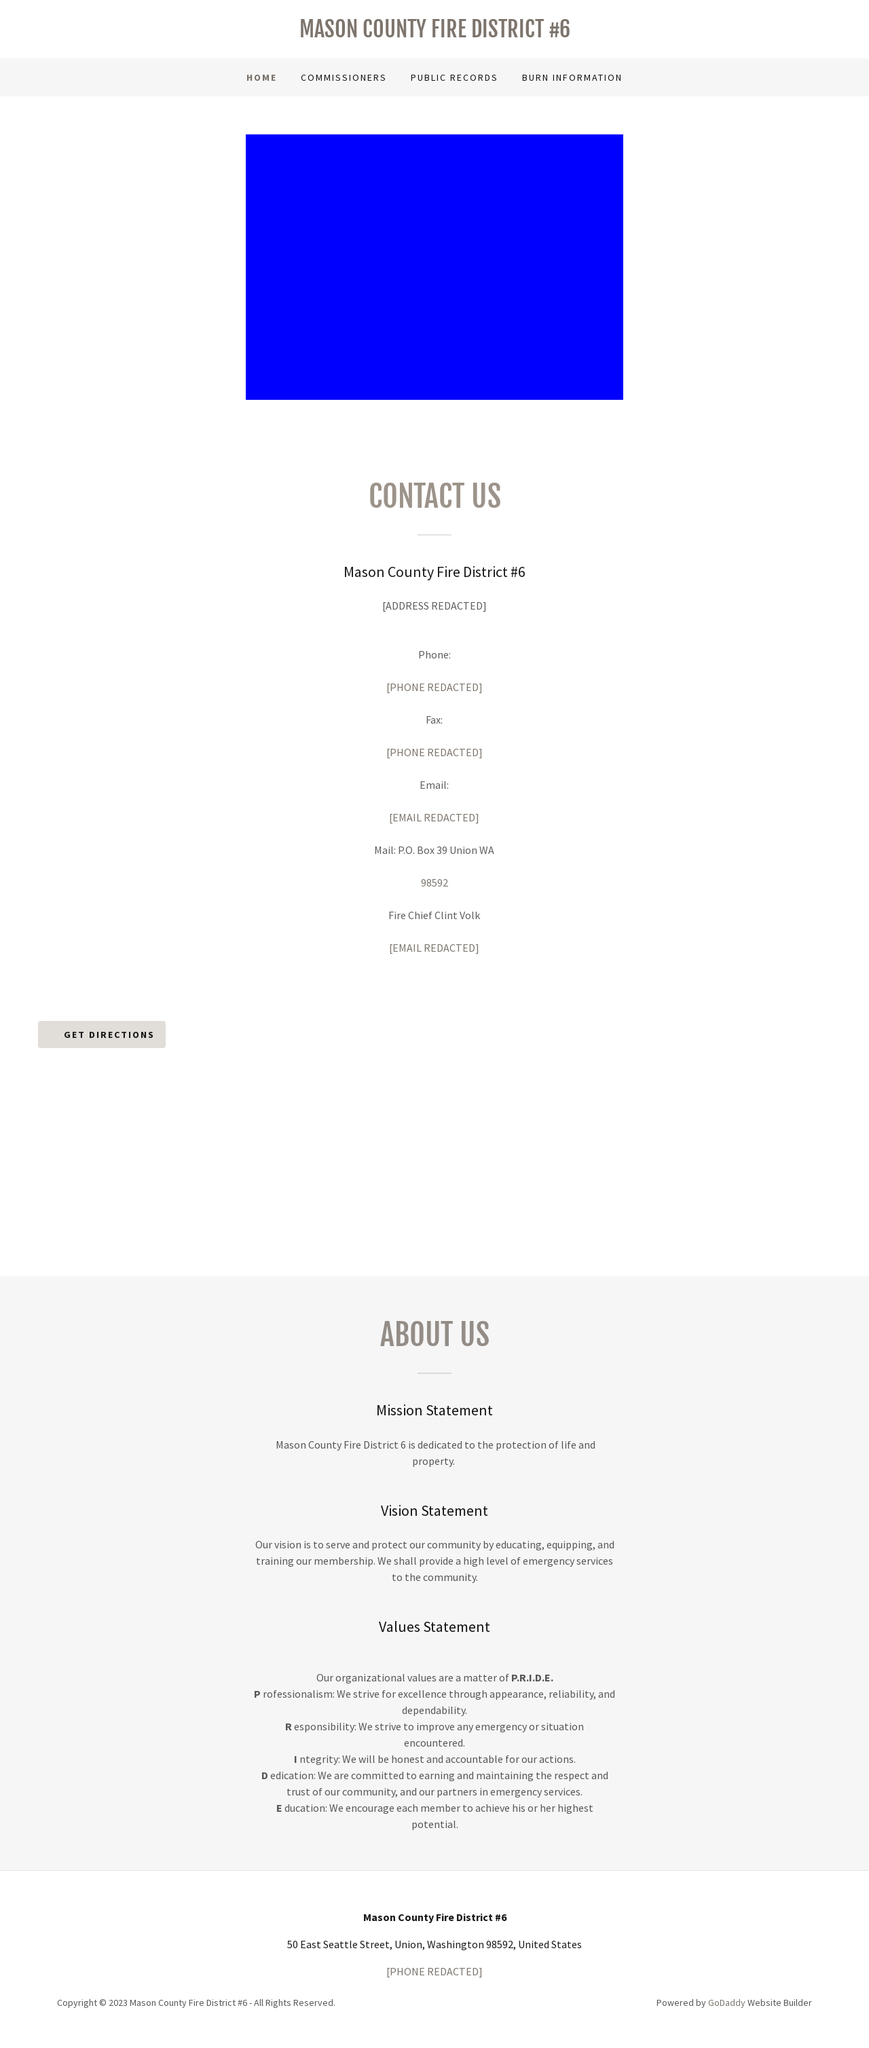Can you tell me more about the 'Get Directions' feature shown in the image? The 'Get Directions' button on the Mason County Fire District #6 website likely redirects users to a map view or external map application where they can input their current location to receive real-time directions. This feature is commonly implemented using Google Maps API or similar services, which facilitates easy navigation and enhances user accessibility to the specified address. 